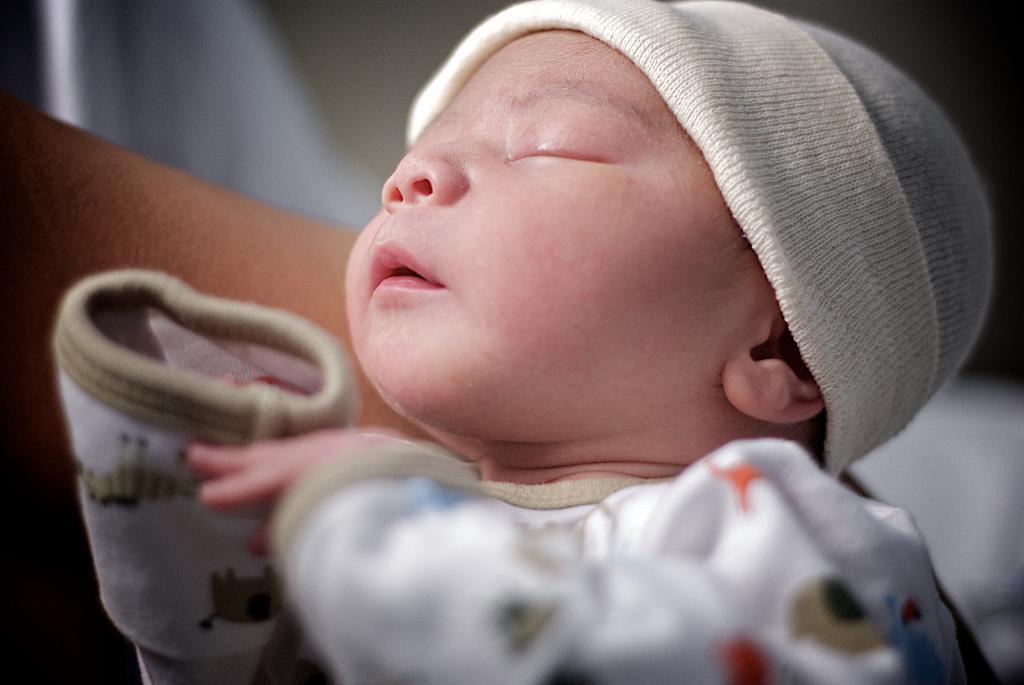In one or two sentences, can you explain what this image depicts? In this picture, we see a baby is wearing a white cap and a white T-shirt. The baby is sleeping. In the background, it is in white and brown color. This picture is blurred in the background. 